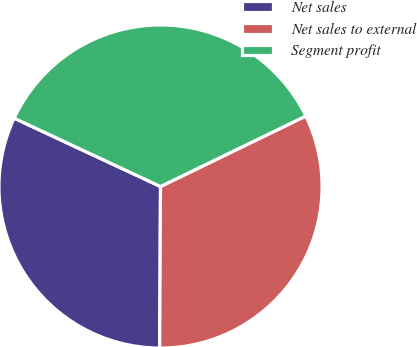Convert chart. <chart><loc_0><loc_0><loc_500><loc_500><pie_chart><fcel>Net sales<fcel>Net sales to external<fcel>Segment profit<nl><fcel>31.87%<fcel>32.27%<fcel>35.86%<nl></chart> 